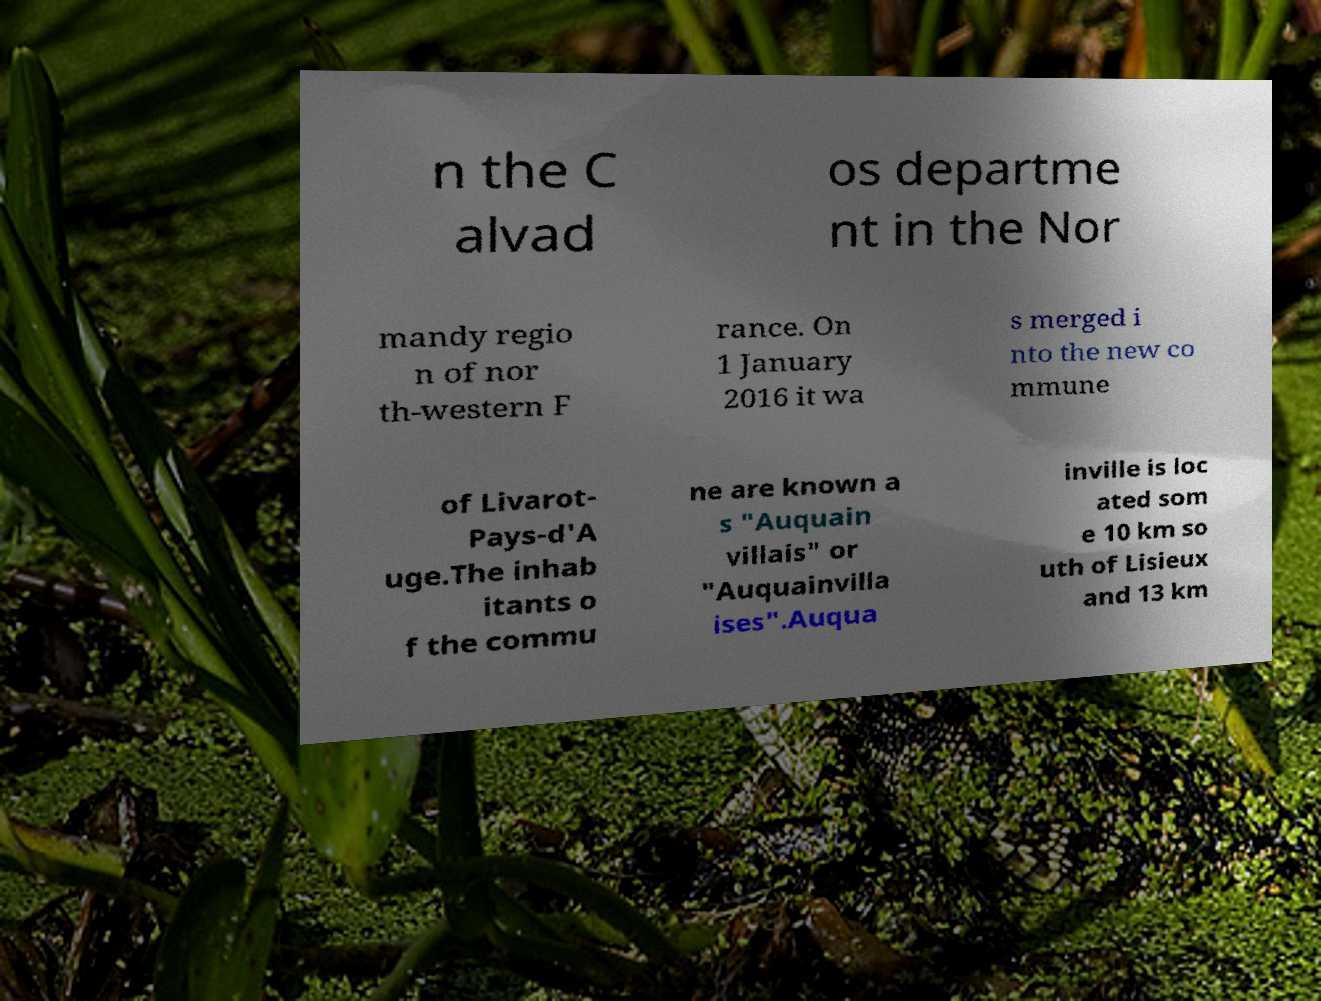For documentation purposes, I need the text within this image transcribed. Could you provide that? n the C alvad os departme nt in the Nor mandy regio n of nor th-western F rance. On 1 January 2016 it wa s merged i nto the new co mmune of Livarot- Pays-d'A uge.The inhab itants o f the commu ne are known a s "Auquain villais" or "Auquainvilla ises".Auqua inville is loc ated som e 10 km so uth of Lisieux and 13 km 